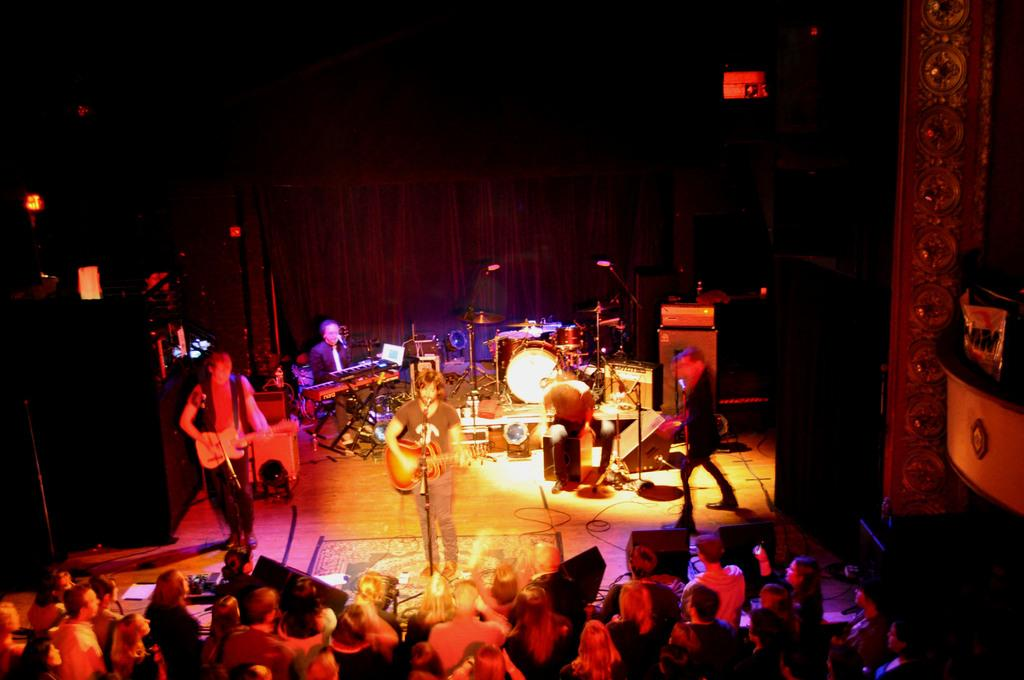How many people are in the image? There is a group of persons in the image. What are the persons in the image doing? The group of persons is performing with musical instruments. What can be seen in the background of the image? There is a wall, a cloth, and light visible in the background of the image. What type of receipt can be seen on the wall in the image? There is no receipt present in the image; the background only features a wall, a cloth, and light. 